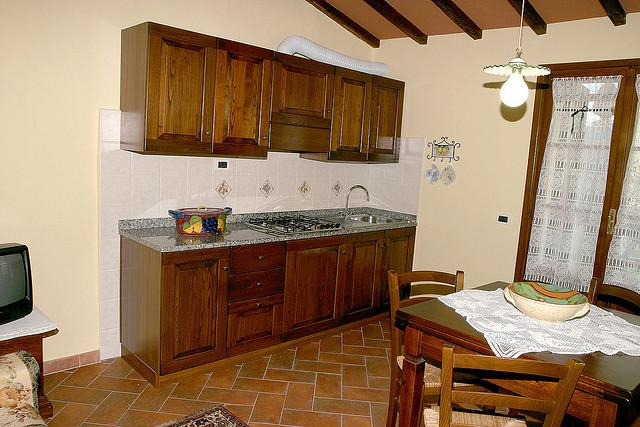What is the white tube on top of the cabinet used for? Please explain your reasoning. ventilation. The tube is for ventilation. 